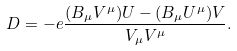Convert formula to latex. <formula><loc_0><loc_0><loc_500><loc_500>D = - e \frac { ( B _ { \mu } V ^ { \mu } ) U - ( B _ { \mu } U ^ { \mu } ) V } { V _ { \mu } V ^ { \mu } } .</formula> 